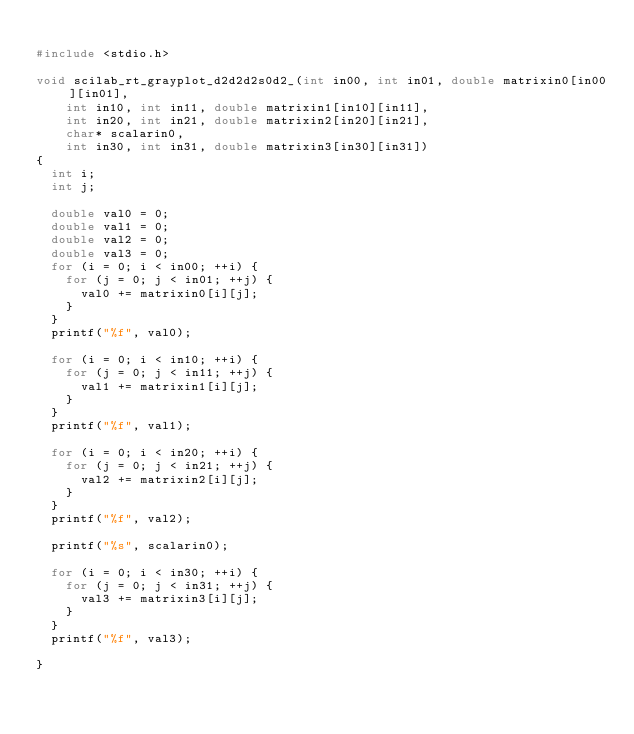<code> <loc_0><loc_0><loc_500><loc_500><_C_>
#include <stdio.h>

void scilab_rt_grayplot_d2d2d2s0d2_(int in00, int in01, double matrixin0[in00][in01], 
    int in10, int in11, double matrixin1[in10][in11], 
    int in20, int in21, double matrixin2[in20][in21], 
    char* scalarin0, 
    int in30, int in31, double matrixin3[in30][in31])
{
  int i;
  int j;

  double val0 = 0;
  double val1 = 0;
  double val2 = 0;
  double val3 = 0;
  for (i = 0; i < in00; ++i) {
    for (j = 0; j < in01; ++j) {
      val0 += matrixin0[i][j];
    }
  }
  printf("%f", val0);

  for (i = 0; i < in10; ++i) {
    for (j = 0; j < in11; ++j) {
      val1 += matrixin1[i][j];
    }
  }
  printf("%f", val1);

  for (i = 0; i < in20; ++i) {
    for (j = 0; j < in21; ++j) {
      val2 += matrixin2[i][j];
    }
  }
  printf("%f", val2);

  printf("%s", scalarin0);

  for (i = 0; i < in30; ++i) {
    for (j = 0; j < in31; ++j) {
      val3 += matrixin3[i][j];
    }
  }
  printf("%f", val3);

}
</code> 